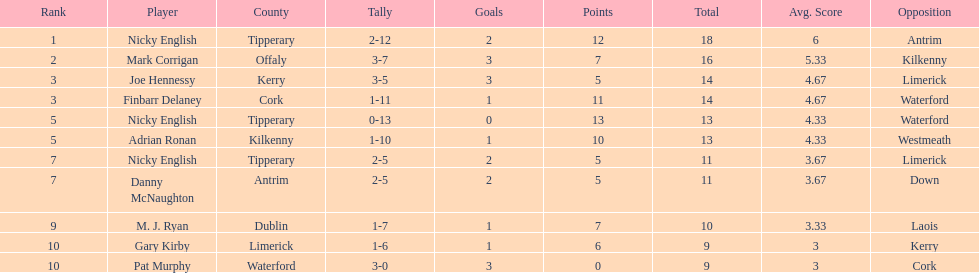What is the least total on the list? 9. 